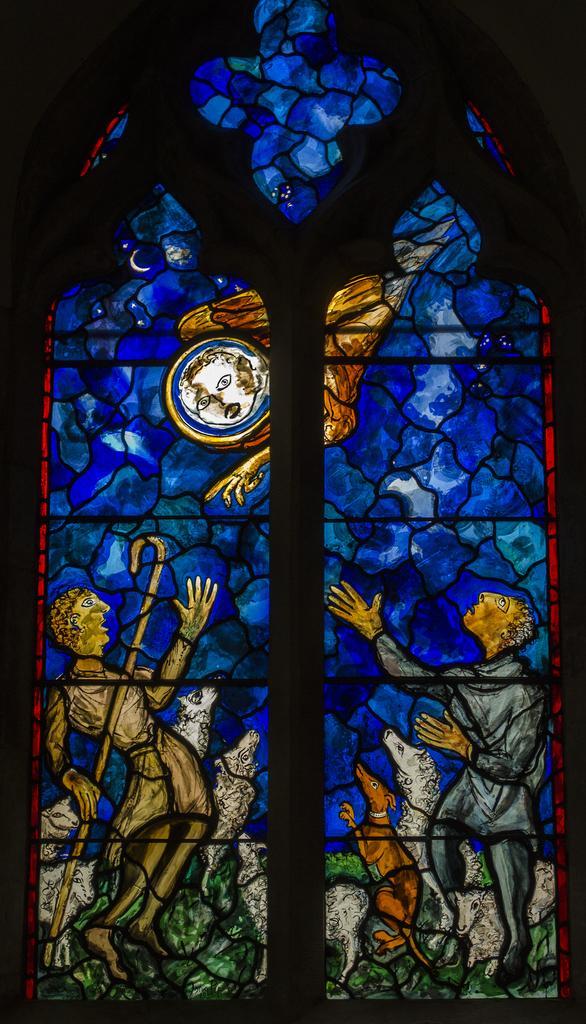Please provide a concise description of this image. In this image we can see a painted glass window. 